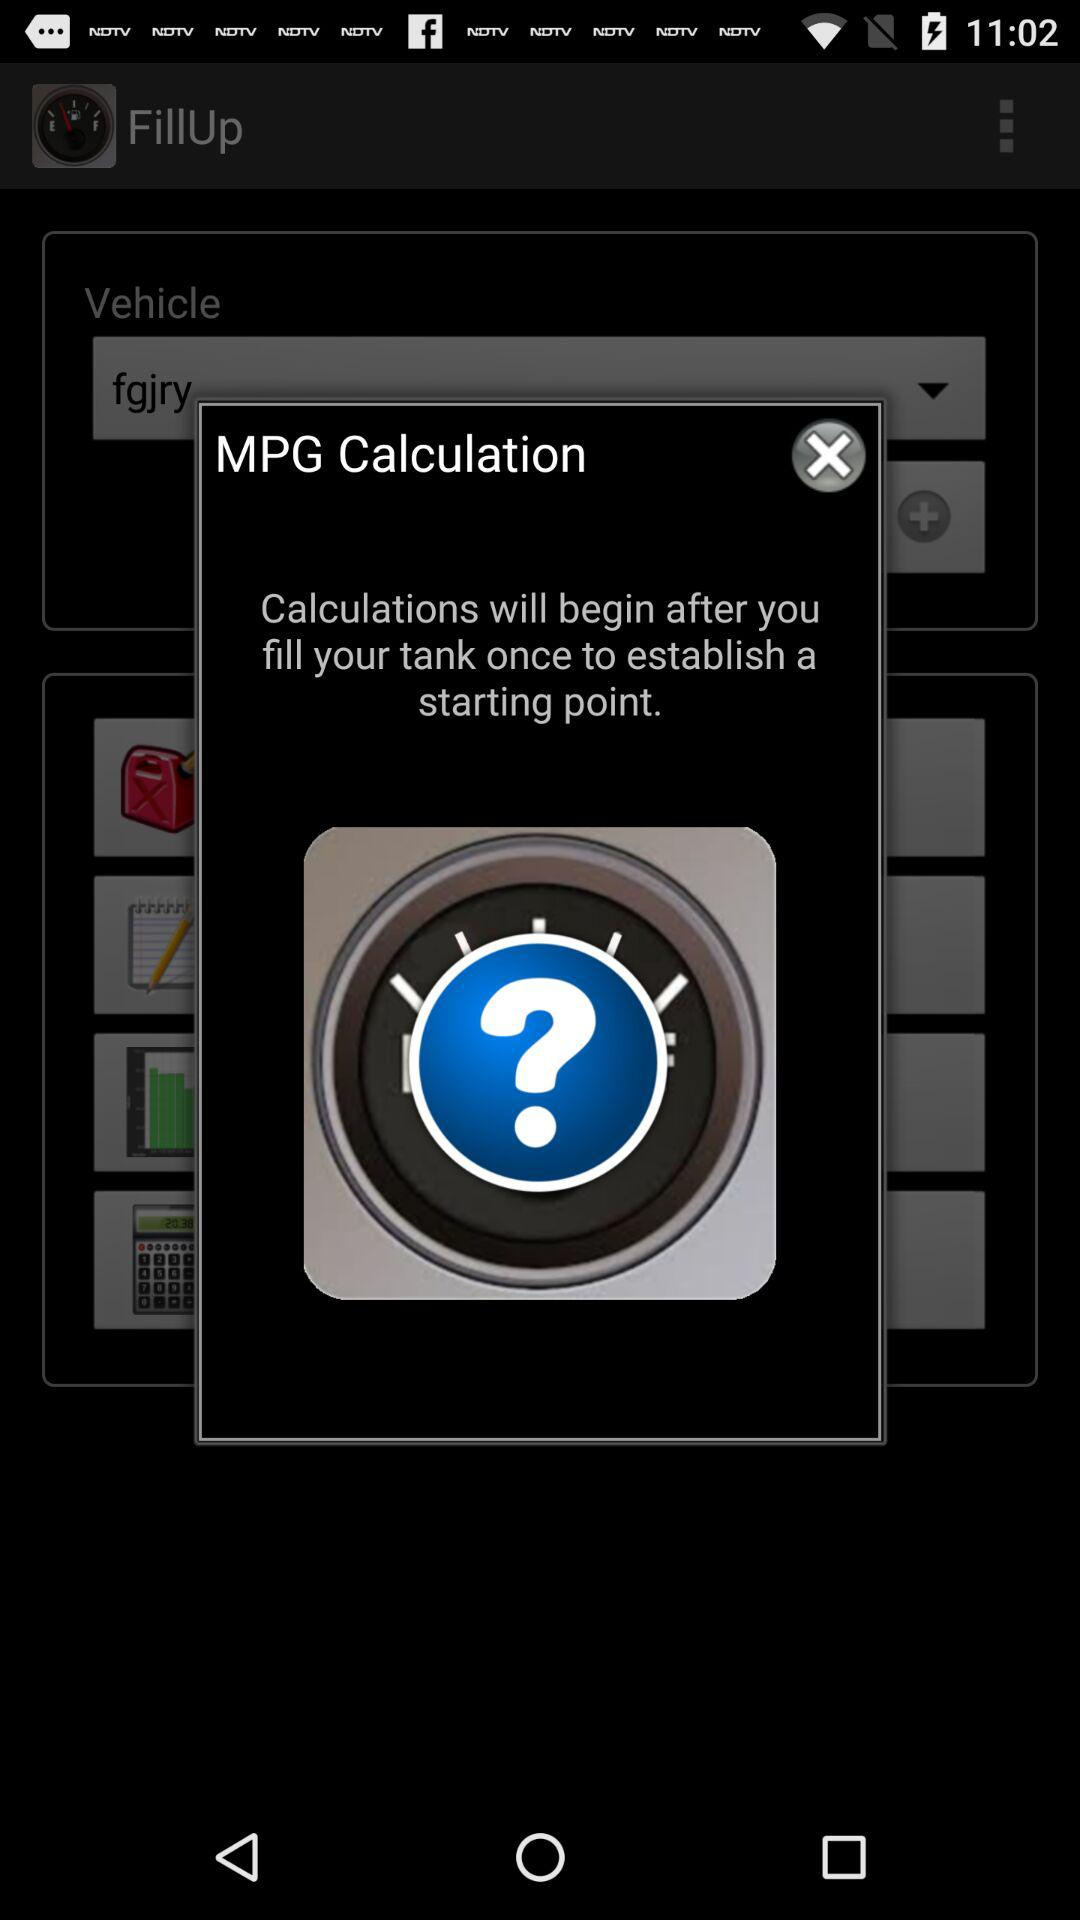What is the application name? The application name is "FillUp". 